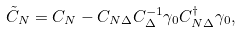<formula> <loc_0><loc_0><loc_500><loc_500>\tilde { C } _ { N } = C _ { N } - C _ { N \Delta } C _ { \Delta } ^ { - 1 } \gamma _ { 0 } C ^ { \dagger } _ { N \Delta } \gamma _ { 0 } ,</formula> 